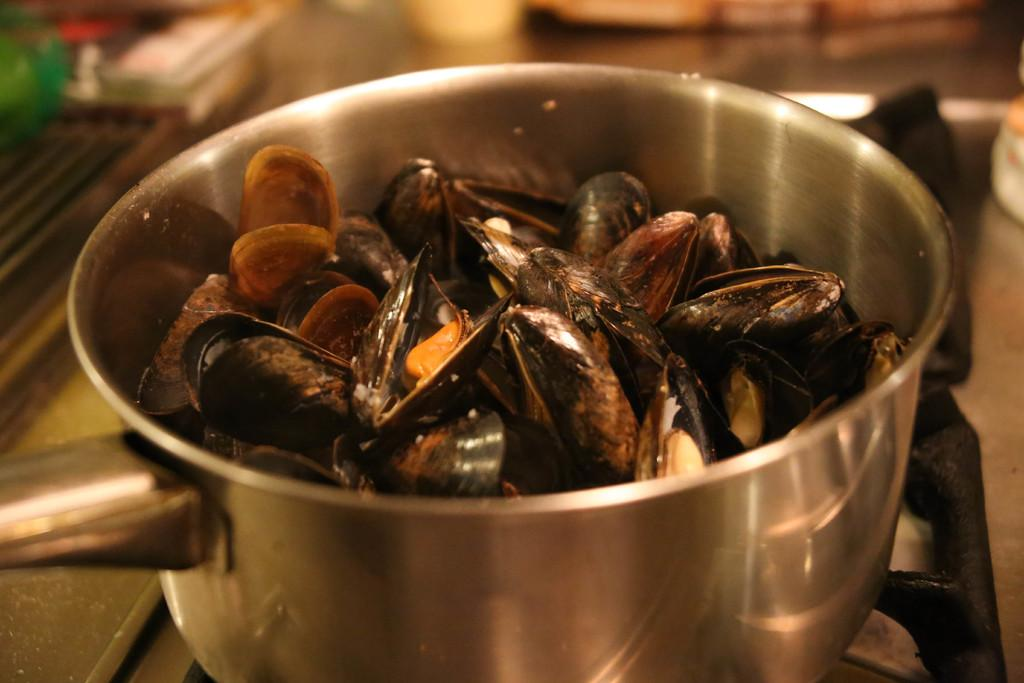What objects can be seen in the image? There are shells in the image. How are the shells arranged? The shells are placed in a bowl. Where is the bowl located? The bowl is on a stove. Can you describe the background of the image? The background of the image is blurred. What type of canvas is used to create the scent in the image? There is no canvas or scent present in the image; it features shells in a bowl on a stove with a blurred background. 